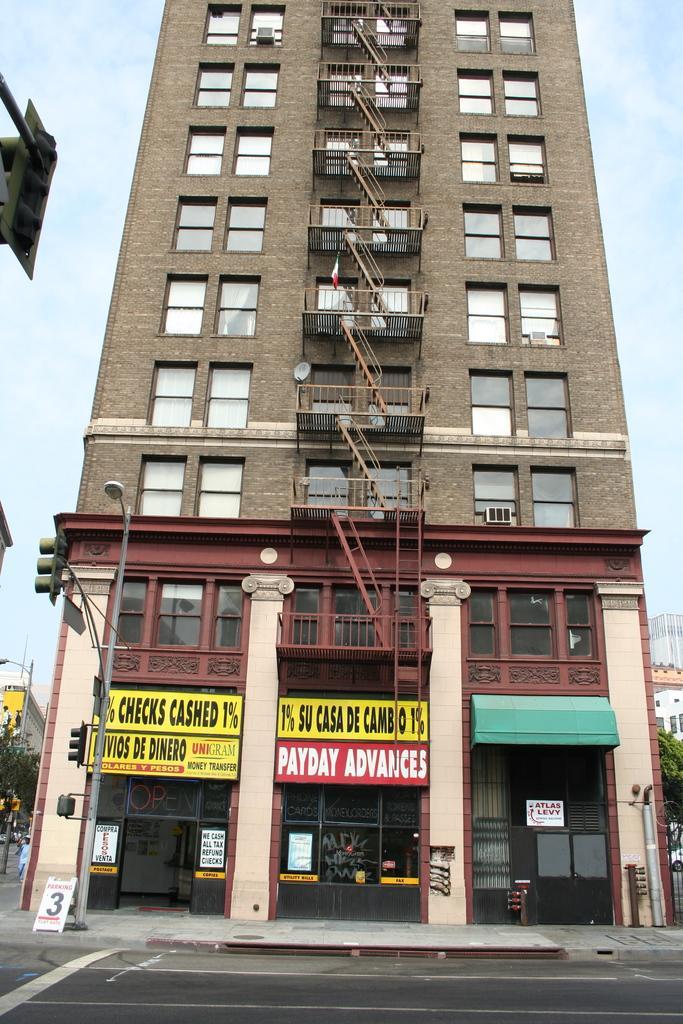In one or two sentences, can you explain what this image depicts? In this image we can see a building with glass windows, railing, name boards and other objects. On the left side of the image there is an object. In the background of the image there are buildings, trees, sky and other objects. In front of the building there is a street light, board, walkway and other objects. At the bottom of the image there is the floor. 